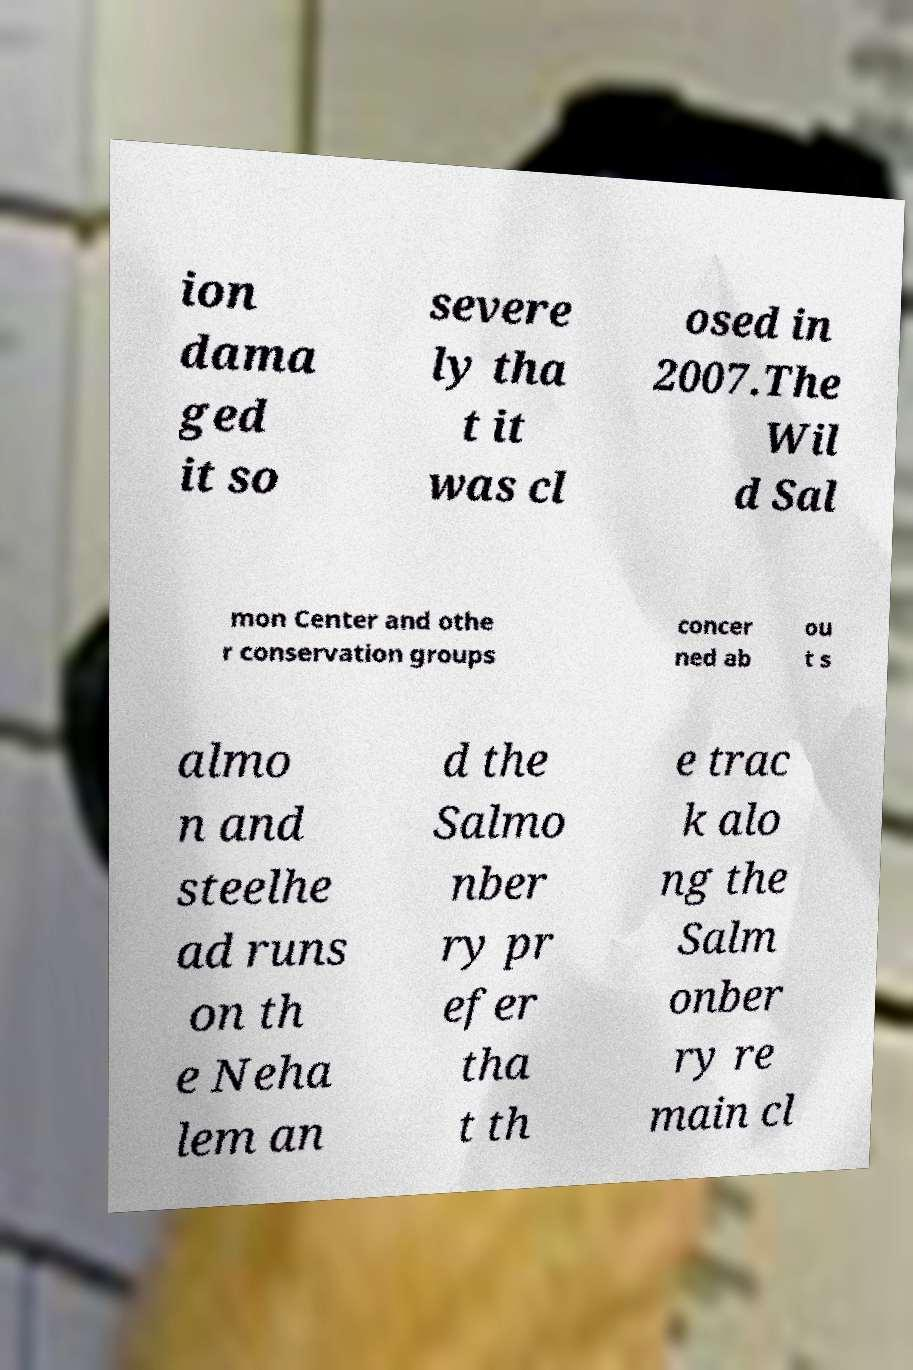For documentation purposes, I need the text within this image transcribed. Could you provide that? ion dama ged it so severe ly tha t it was cl osed in 2007.The Wil d Sal mon Center and othe r conservation groups concer ned ab ou t s almo n and steelhe ad runs on th e Neha lem an d the Salmo nber ry pr efer tha t th e trac k alo ng the Salm onber ry re main cl 